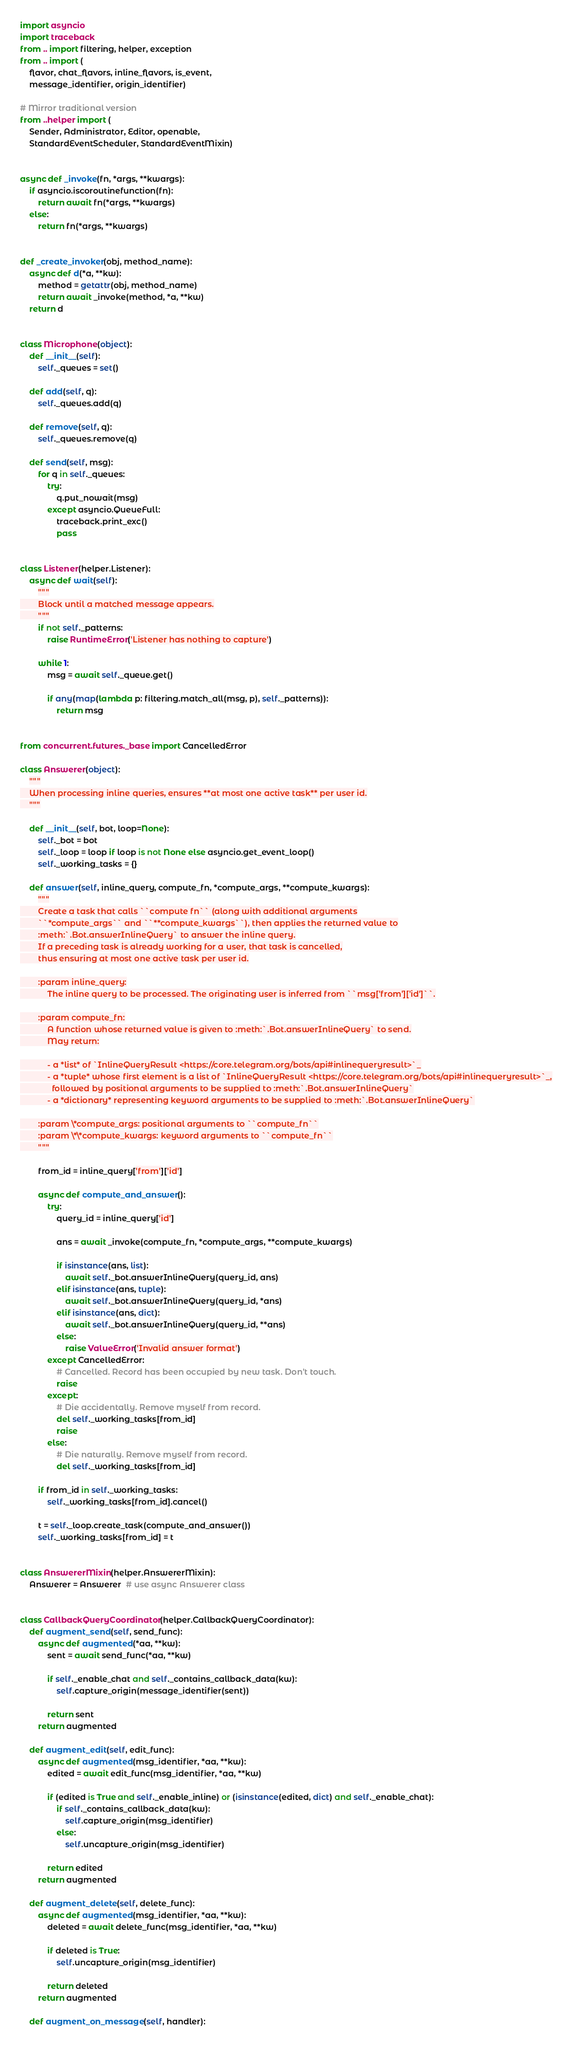<code> <loc_0><loc_0><loc_500><loc_500><_Python_>import asyncio
import traceback
from .. import filtering, helper, exception
from .. import (
    flavor, chat_flavors, inline_flavors, is_event,
    message_identifier, origin_identifier)

# Mirror traditional version
from ..helper import (
    Sender, Administrator, Editor, openable,
    StandardEventScheduler, StandardEventMixin)


async def _invoke(fn, *args, **kwargs):
    if asyncio.iscoroutinefunction(fn):
        return await fn(*args, **kwargs)
    else:
        return fn(*args, **kwargs)


def _create_invoker(obj, method_name):
    async def d(*a, **kw):
        method = getattr(obj, method_name)
        return await _invoke(method, *a, **kw)
    return d


class Microphone(object):
    def __init__(self):
        self._queues = set()

    def add(self, q):
        self._queues.add(q)

    def remove(self, q):
        self._queues.remove(q)

    def send(self, msg):
        for q in self._queues:
            try:
                q.put_nowait(msg)
            except asyncio.QueueFull:
                traceback.print_exc()
                pass


class Listener(helper.Listener):
    async def wait(self):
        """
        Block until a matched message appears.
        """
        if not self._patterns:
            raise RuntimeError('Listener has nothing to capture')

        while 1:
            msg = await self._queue.get()

            if any(map(lambda p: filtering.match_all(msg, p), self._patterns)):
                return msg


from concurrent.futures._base import CancelledError

class Answerer(object):
    """
    When processing inline queries, ensures **at most one active task** per user id.
    """

    def __init__(self, bot, loop=None):
        self._bot = bot
        self._loop = loop if loop is not None else asyncio.get_event_loop()
        self._working_tasks = {}

    def answer(self, inline_query, compute_fn, *compute_args, **compute_kwargs):
        """
        Create a task that calls ``compute fn`` (along with additional arguments
        ``*compute_args`` and ``**compute_kwargs``), then applies the returned value to
        :meth:`.Bot.answerInlineQuery` to answer the inline query.
        If a preceding task is already working for a user, that task is cancelled,
        thus ensuring at most one active task per user id.

        :param inline_query:
            The inline query to be processed. The originating user is inferred from ``msg['from']['id']``.

        :param compute_fn:
            A function whose returned value is given to :meth:`.Bot.answerInlineQuery` to send.
            May return:

            - a *list* of `InlineQueryResult <https://core.telegram.org/bots/api#inlinequeryresult>`_
            - a *tuple* whose first element is a list of `InlineQueryResult <https://core.telegram.org/bots/api#inlinequeryresult>`_,
              followed by positional arguments to be supplied to :meth:`.Bot.answerInlineQuery`
            - a *dictionary* representing keyword arguments to be supplied to :meth:`.Bot.answerInlineQuery`

        :param \*compute_args: positional arguments to ``compute_fn``
        :param \*\*compute_kwargs: keyword arguments to ``compute_fn``
        """

        from_id = inline_query['from']['id']

        async def compute_and_answer():
            try:
                query_id = inline_query['id']

                ans = await _invoke(compute_fn, *compute_args, **compute_kwargs)

                if isinstance(ans, list):
                    await self._bot.answerInlineQuery(query_id, ans)
                elif isinstance(ans, tuple):
                    await self._bot.answerInlineQuery(query_id, *ans)
                elif isinstance(ans, dict):
                    await self._bot.answerInlineQuery(query_id, **ans)
                else:
                    raise ValueError('Invalid answer format')
            except CancelledError:
                # Cancelled. Record has been occupied by new task. Don't touch.
                raise
            except:
                # Die accidentally. Remove myself from record.
                del self._working_tasks[from_id]
                raise
            else:
                # Die naturally. Remove myself from record.
                del self._working_tasks[from_id]

        if from_id in self._working_tasks:
            self._working_tasks[from_id].cancel()

        t = self._loop.create_task(compute_and_answer())
        self._working_tasks[from_id] = t


class AnswererMixin(helper.AnswererMixin):
    Answerer = Answerer  # use async Answerer class


class CallbackQueryCoordinator(helper.CallbackQueryCoordinator):
    def augment_send(self, send_func):
        async def augmented(*aa, **kw):
            sent = await send_func(*aa, **kw)

            if self._enable_chat and self._contains_callback_data(kw):
                self.capture_origin(message_identifier(sent))

            return sent
        return augmented

    def augment_edit(self, edit_func):
        async def augmented(msg_identifier, *aa, **kw):
            edited = await edit_func(msg_identifier, *aa, **kw)

            if (edited is True and self._enable_inline) or (isinstance(edited, dict) and self._enable_chat):
                if self._contains_callback_data(kw):
                    self.capture_origin(msg_identifier)
                else:
                    self.uncapture_origin(msg_identifier)

            return edited
        return augmented

    def augment_delete(self, delete_func):
        async def augmented(msg_identifier, *aa, **kw):
            deleted = await delete_func(msg_identifier, *aa, **kw)

            if deleted is True:
                self.uncapture_origin(msg_identifier)

            return deleted
        return augmented

    def augment_on_message(self, handler):</code> 